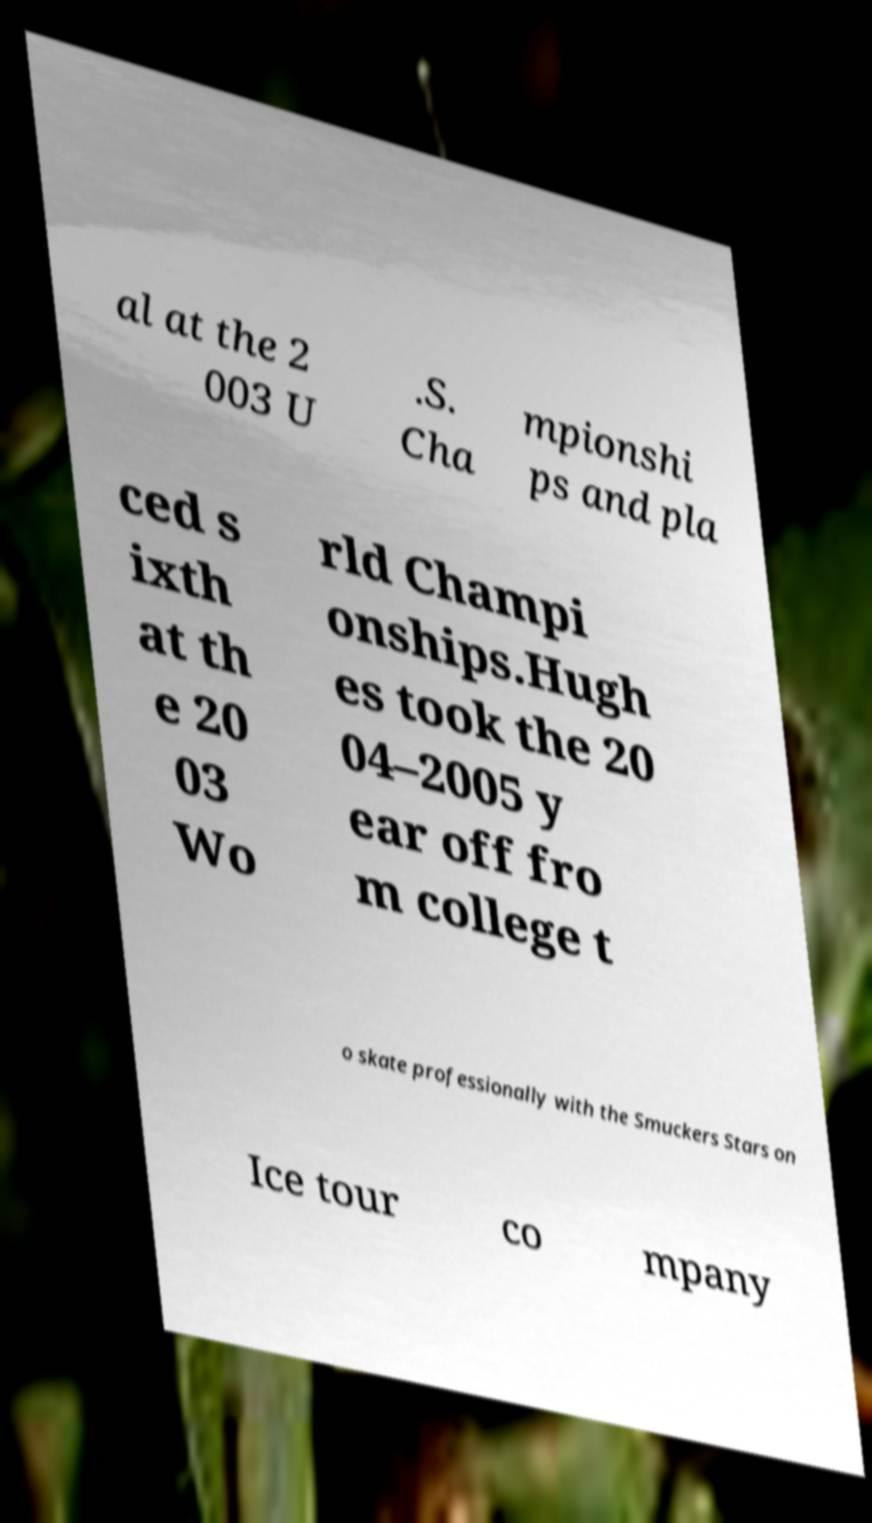For documentation purposes, I need the text within this image transcribed. Could you provide that? al at the 2 003 U .S. Cha mpionshi ps and pla ced s ixth at th e 20 03 Wo rld Champi onships.Hugh es took the 20 04–2005 y ear off fro m college t o skate professionally with the Smuckers Stars on Ice tour co mpany 